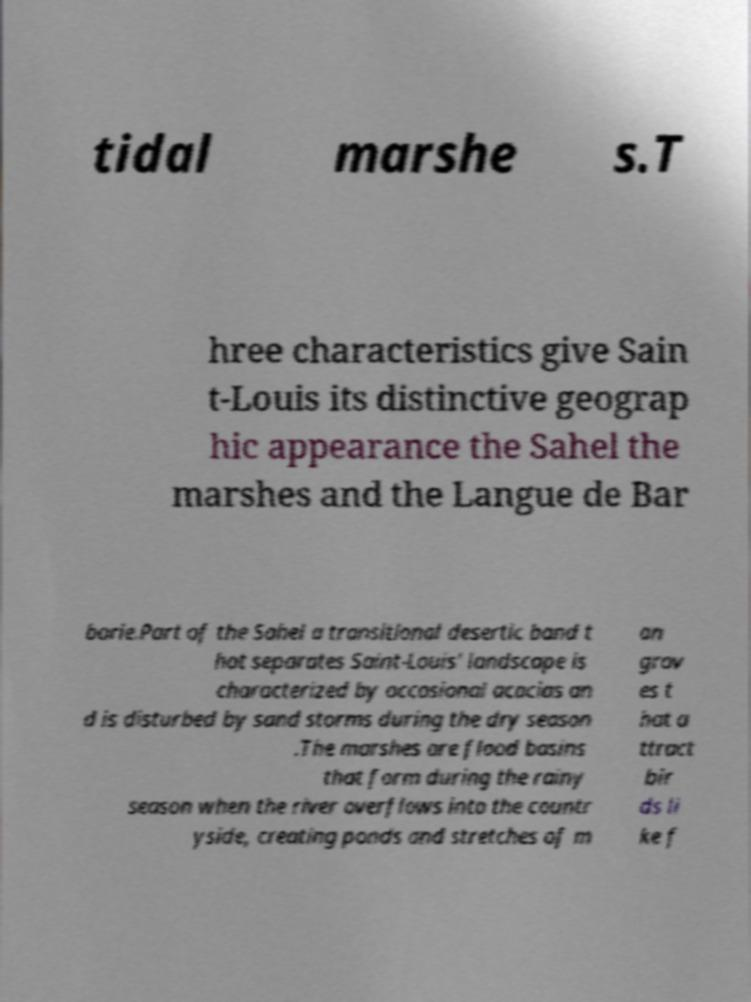Please read and relay the text visible in this image. What does it say? tidal marshe s.T hree characteristics give Sain t-Louis its distinctive geograp hic appearance the Sahel the marshes and the Langue de Bar barie.Part of the Sahel a transitional desertic band t hat separates Saint-Louis' landscape is characterized by occasional acacias an d is disturbed by sand storms during the dry season .The marshes are flood basins that form during the rainy season when the river overflows into the countr yside, creating ponds and stretches of m an grov es t hat a ttract bir ds li ke f 